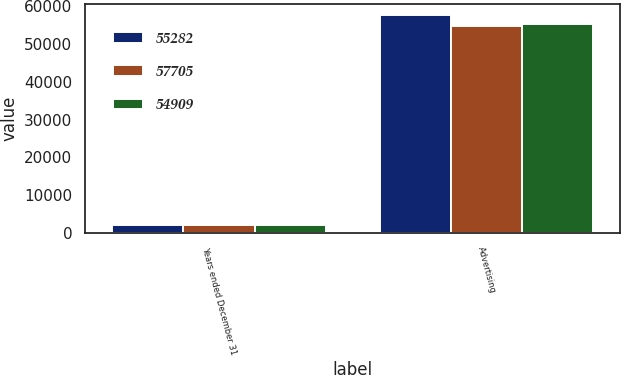Convert chart. <chart><loc_0><loc_0><loc_500><loc_500><stacked_bar_chart><ecel><fcel>Years ended December 31<fcel>Advertising<nl><fcel>55282<fcel>2015<fcel>57705<nl><fcel>57705<fcel>2014<fcel>54909<nl><fcel>54909<fcel>2013<fcel>55282<nl></chart> 